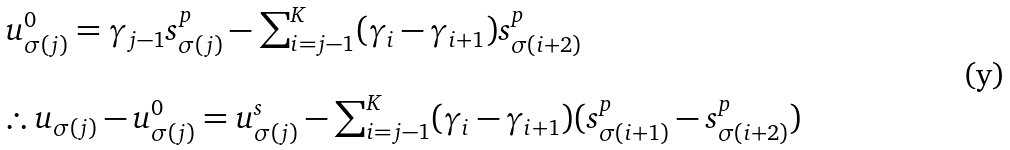Convert formula to latex. <formula><loc_0><loc_0><loc_500><loc_500>\begin{array} { l } u _ { \sigma ( j ) } ^ { 0 } = \gamma _ { j - 1 } s _ { \sigma ( j ) } ^ { p } - \sum _ { i = j - 1 } ^ { K } ( \gamma _ { i } - \gamma _ { i + 1 } ) s _ { \sigma ( i + 2 ) } ^ { p } \\ \\ \therefore u _ { \sigma ( j ) } - u _ { \sigma ( j ) } ^ { 0 } = u _ { \sigma ( j ) } ^ { s } - \sum _ { i = j - 1 } ^ { K } ( \gamma _ { i } - \gamma _ { i + 1 } ) ( s _ { \sigma ( i + 1 ) } ^ { p } - s _ { \sigma ( i + 2 ) } ^ { p } ) \end{array}</formula> 